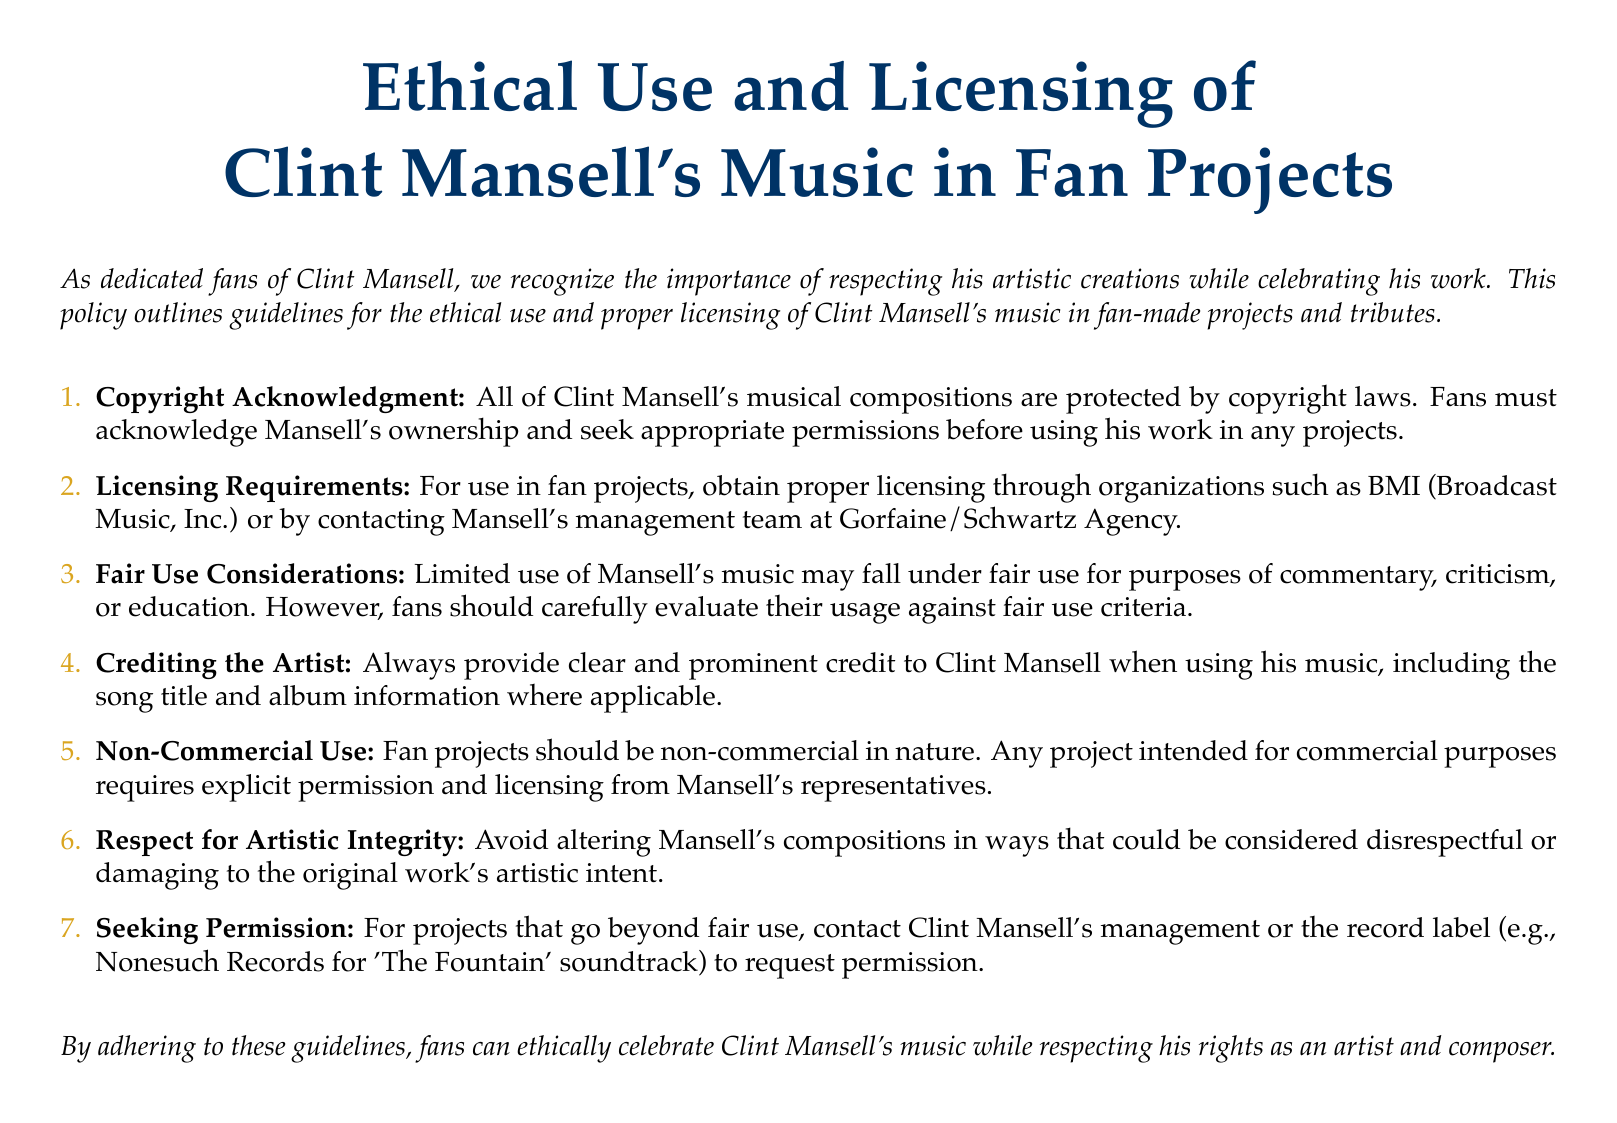What is the title of the policy document? The title is explicitly stated at the beginning of the document and provides the main focus of the content.
Answer: Ethical Use and Licensing of Clint Mansell's Music in Fan Projects How many main points are outlined in the document? The document includes a list of guidelines numbered in a sequence, counting the distinct main points.
Answer: 7 Which agency should be contacted for licensing requirements? The document mentions an organization related to licensing that fans should reach out to for permissions.
Answer: Gorfaine/Schwartz Agency What type of use does the document specify as non-commercial? The guidelines clearly state the nature of fan projects allowed without commercial intents.
Answer: Non-commercial What must fans provide when using Mansell's music? The guidelines emphasize the importance of crediting the artist when utilizing his compositions.
Answer: Clear and prominent credit What is one reason limited use of Mansell's music may be permitted? The document outlines specific contexts under which limited use could be considered acceptable.
Answer: Fair use What is the color used for section titles in the document? The document specifies a color that is used for formatting the titles of sections throughout the text.
Answer: Mansell blue 